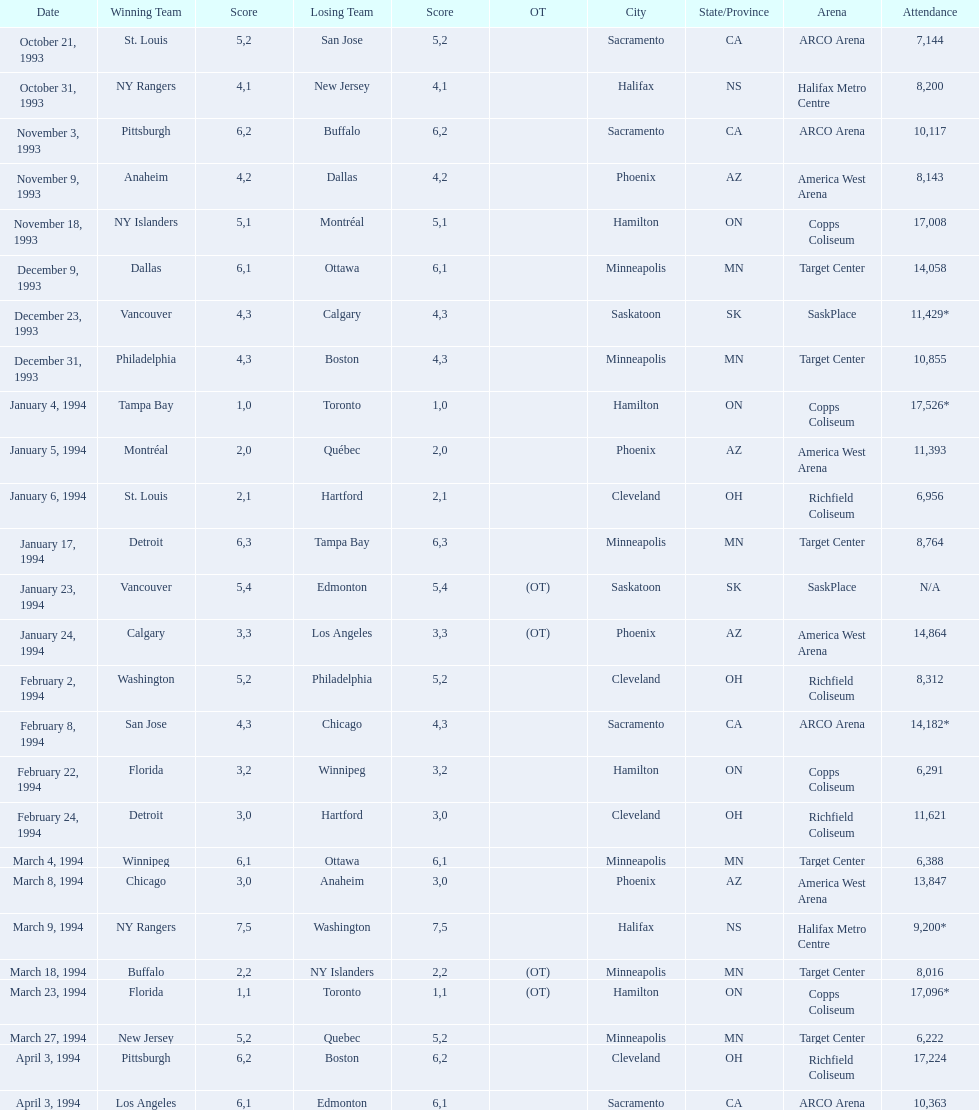How many games have been held in minneapolis? 6. 